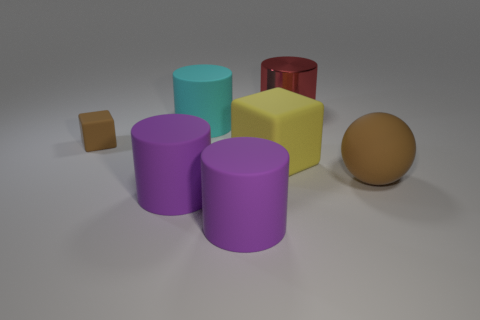Subtract all cyan matte cylinders. How many cylinders are left? 3 Subtract all red blocks. How many purple cylinders are left? 2 Subtract all red cylinders. How many cylinders are left? 3 Add 2 shiny cylinders. How many objects exist? 9 Subtract all cubes. How many objects are left? 5 Add 7 cyan things. How many cyan things are left? 8 Add 3 small rubber objects. How many small rubber objects exist? 4 Subtract 1 red cylinders. How many objects are left? 6 Subtract all red cylinders. Subtract all yellow spheres. How many cylinders are left? 3 Subtract all large purple matte cylinders. Subtract all big brown spheres. How many objects are left? 4 